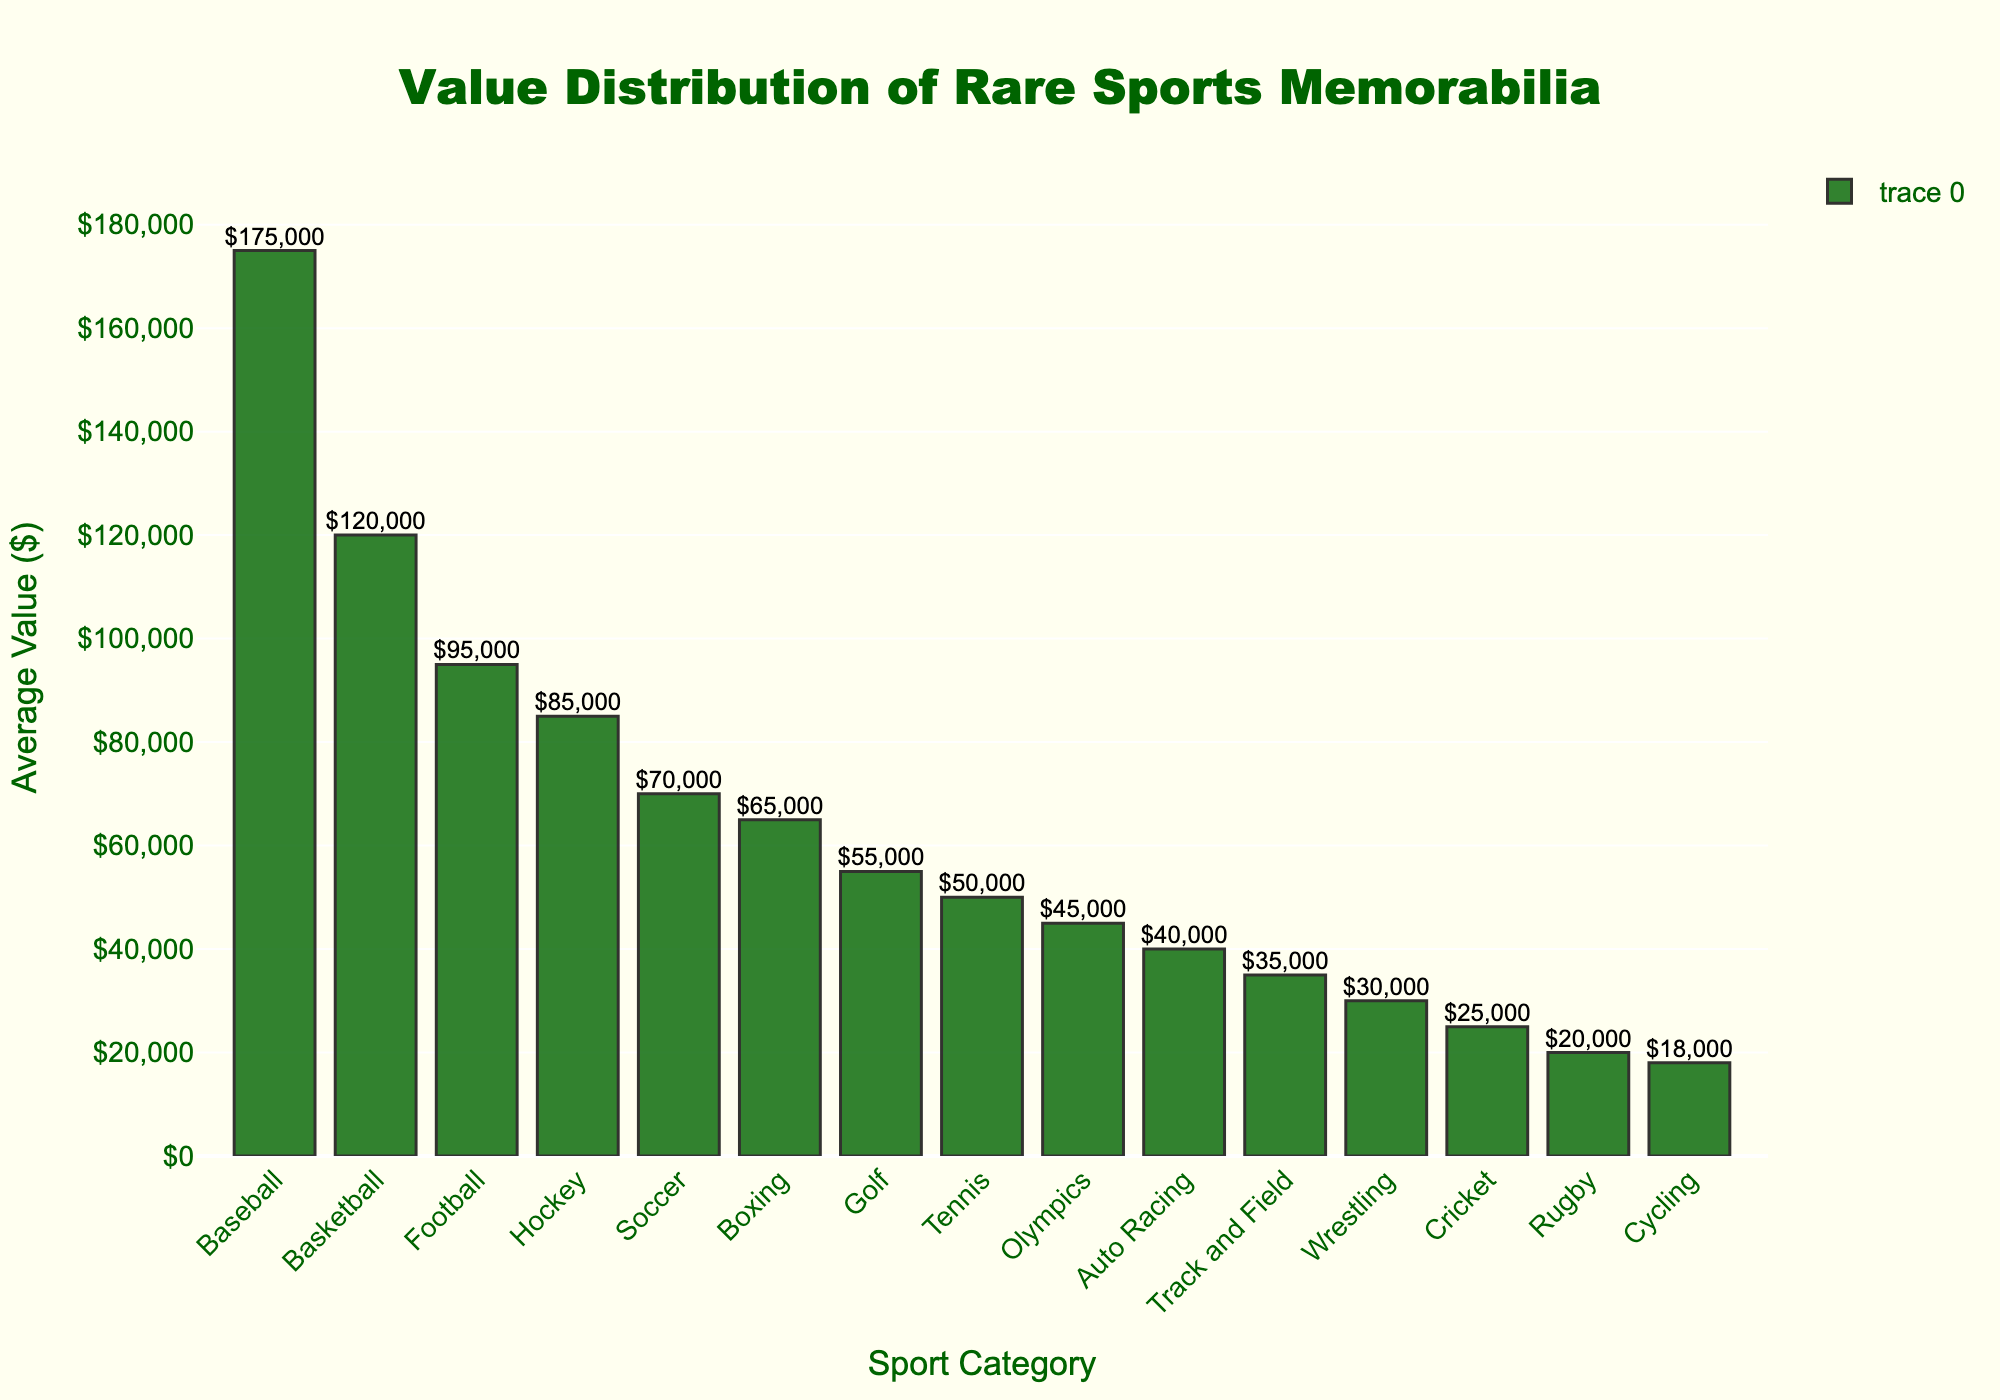Which sport category has the highest average value for rare sports memorabilia? The highest bar represents the sport category with the highest average value. Based on the height of the bars, the "Baseball" category has the highest average value listed at $175,000.
Answer: Baseball Which sport category has the lowest average value for rare sports memorabilia? The shortest bar represents the sport category with the lowest average value. The "Cycling" category has the lowest average value listed at $18,000.
Answer: Cycling What is the difference in average value between Baseball and Basketball memorabilia? Subtract the average value of Basketball ($120,000) from Baseball ($175,000). The difference is $175,000 - $120,000 = $55,000.
Answer: $55,000 Which sport categories have average values greater than $50,000 but less than $100,000? Identify the bars with heights corresponding to values greater than $50,000 and less than $100,000. The categories are Football ($95,000), Hockey ($85,000), Soccer ($70,000), and Boxing ($65,000).
Answer: Football, Hockey, Soccer, Boxing What is the combined average value of Golf, Tennis, and Auto Racing memorabilia? Add the average values: Golf ($55,000) + Tennis ($50,000) + Auto Racing ($40,000). The total combined value is $55,000 + $50,000 + $40,000 = $145,000.
Answer: $145,000 How many sport categories have an average value of $50,000 or less? Count the number of bars with heights corresponding to values of $50,000 or less. The sport categories are Tennis, Olympics, Auto Racing, Track and Field, Wrestling, Cricket, Rugby, and Cycling, which are 8 in total.
Answer: 8 What is the average value of rare memorabilia for the top three sport categories? Add the average values of the top three sports: Baseball ($175,000), Basketball ($120,000), and Football ($95,000). Then, divide by 3 to find the average: ($175,000 + $120,000 + $95,000) / 3 = $390,000 / 3 = $130,000.
Answer: $130,000 Which two sport categories have the smallest difference in their average values? Compare the heights of the bars and find the smallest differences. Golf and Tennis have the smallest difference: Golf ($55,000) - Tennis ($50,000) = $5,000.
Answer: Golf and Tennis What percentage of the highest average value is the average value of Cricket memorabilia? Divide the average value of Cricket ($25,000) by the highest average value (Baseball: $175,000) and multiply by 100: ($25,000 / $175,000) * 100 ≈ 14.29%.
Answer: 14.29% What is the sum of the average values for the three lowest-valued sport categories? Add the average values of Rugby ($20,000), Cycling ($18,000), and Cricket ($25,000). The total is $20,000 + $18,000 + $25,000 = $63,000.
Answer: $63,000 